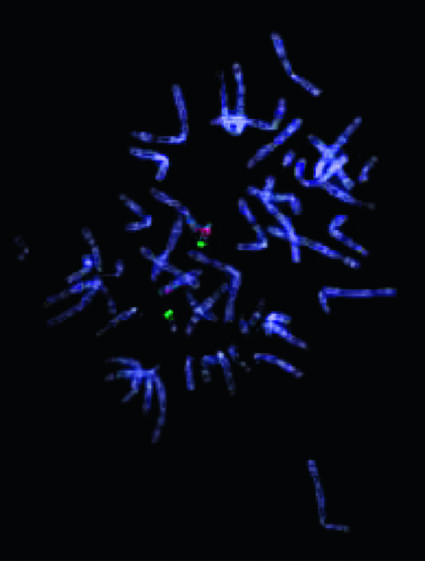does one of the two chromosomes not stain with the probe for 22q11 .2, indicating a microdeletion in this region?
Answer the question using a single word or phrase. Yes 